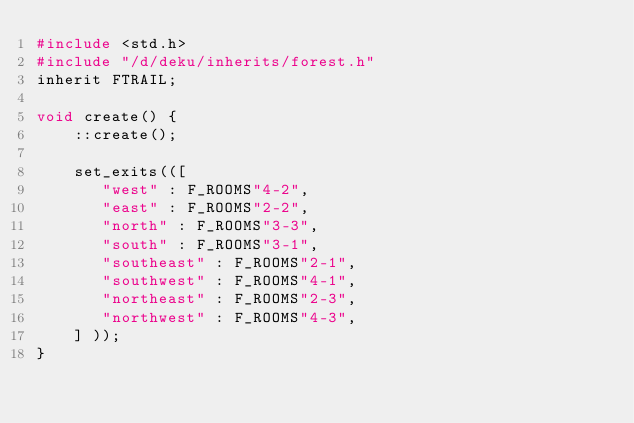<code> <loc_0><loc_0><loc_500><loc_500><_C_>#include <std.h>
#include "/d/deku/inherits/forest.h"
inherit FTRAIL;

void create() {
    ::create();

    set_exits(([
       "west" : F_ROOMS"4-2",
       "east" : F_ROOMS"2-2",
       "north" : F_ROOMS"3-3",
       "south" : F_ROOMS"3-1",
       "southeast" : F_ROOMS"2-1",
       "southwest" : F_ROOMS"4-1",
       "northeast" : F_ROOMS"2-3",
       "northwest" : F_ROOMS"4-3",
    ] ));
}
</code> 